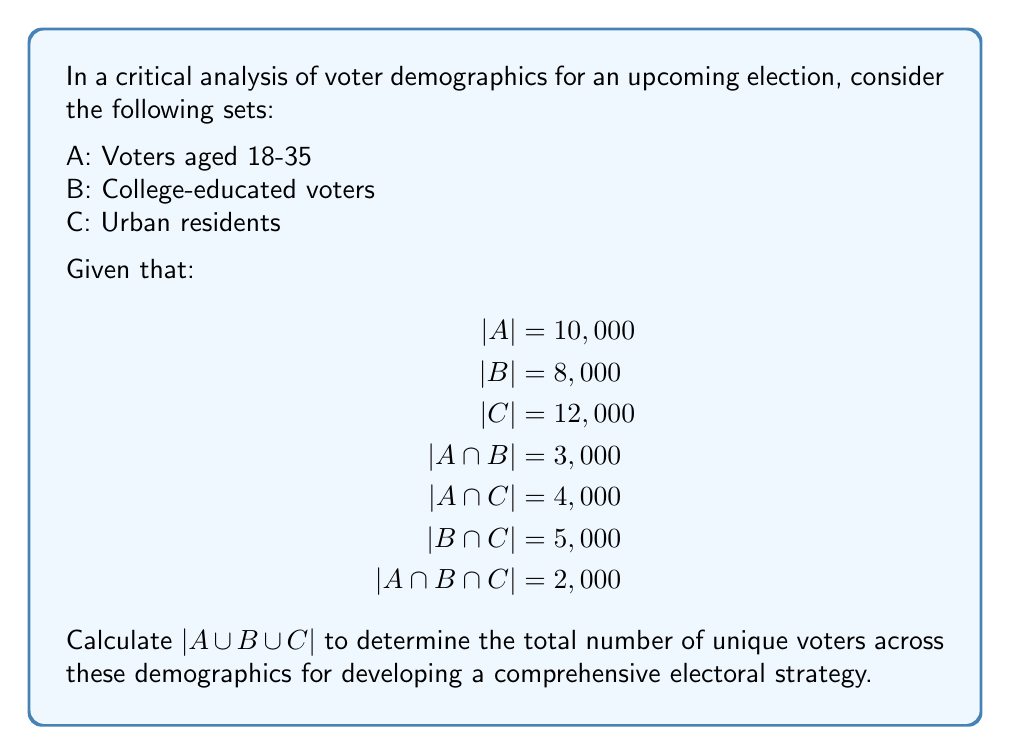Provide a solution to this math problem. To calculate the union of these three sets, we will use the Inclusion-Exclusion Principle:

$|A \cup B \cup C| = |A| + |B| + |C| - |A \cap B| - |A \cap C| - |B \cap C| + |A \cap B \cap C|$

Let's substitute the given values:

$|A \cup B \cup C| = 10,000 + 8,000 + 12,000 - 3,000 - 4,000 - 5,000 + 2,000$

Now, let's perform the arithmetic:

1. Sum of individual sets:
   $10,000 + 8,000 + 12,000 = 30,000$

2. Subtract the double-counted intersections:
   $30,000 - 3,000 - 4,000 - 5,000 = 18,000$

3. Add back the triple-counted intersection:
   $18,000 + 2,000 = 20,000$

Therefore, $|A \cup B \cup C| = 20,000$
Answer: $|A \cup B \cup C| = 20,000$ unique voters 